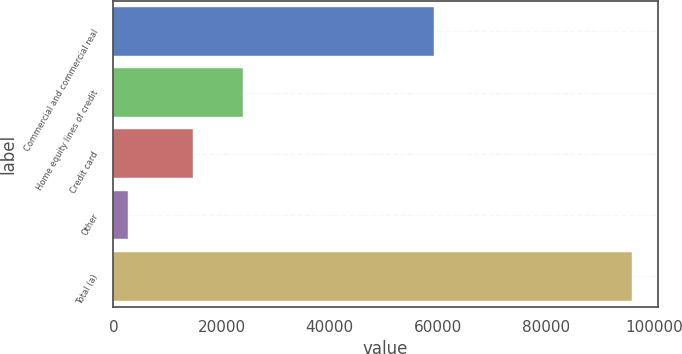Convert chart to OTSL. <chart><loc_0><loc_0><loc_500><loc_500><bar_chart><fcel>Commercial and commercial real<fcel>Home equity lines of credit<fcel>Credit card<fcel>Other<fcel>Total (a)<nl><fcel>59256<fcel>24040.3<fcel>14725<fcel>2652<fcel>95805<nl></chart> 